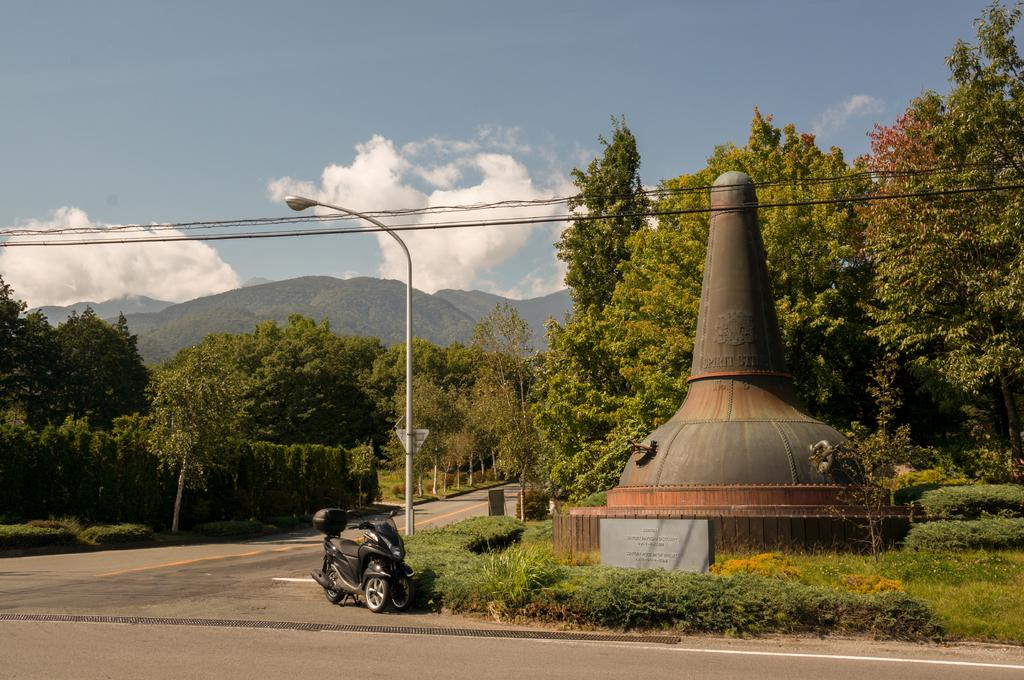What is the main subject of the image? There is a sculpture in the image. What else can be seen in the image besides the sculpture? There is a bike, trees, plants, and mountains in the image. Are there any fairies flying around the sculpture in the image? There are no fairies present in the image. What type of joke can be seen on the bike in the image? There is no joke present on the bike in the image. 